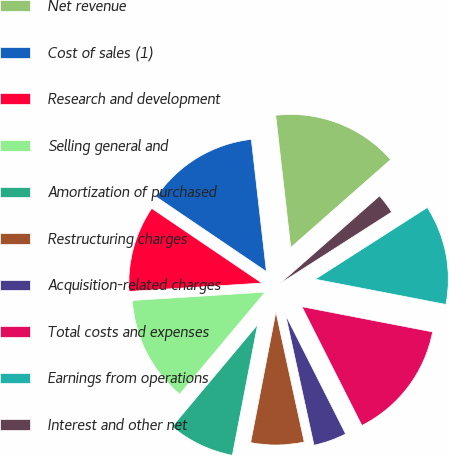Convert chart. <chart><loc_0><loc_0><loc_500><loc_500><pie_chart><fcel>Net revenue<fcel>Cost of sales (1)<fcel>Research and development<fcel>Selling general and<fcel>Amortization of purchased<fcel>Restructuring charges<fcel>Acquisition-related charges<fcel>Total costs and expenses<fcel>Earnings from operations<fcel>Interest and other net<nl><fcel>15.32%<fcel>13.71%<fcel>10.48%<fcel>12.9%<fcel>8.06%<fcel>6.45%<fcel>4.03%<fcel>14.52%<fcel>12.1%<fcel>2.42%<nl></chart> 